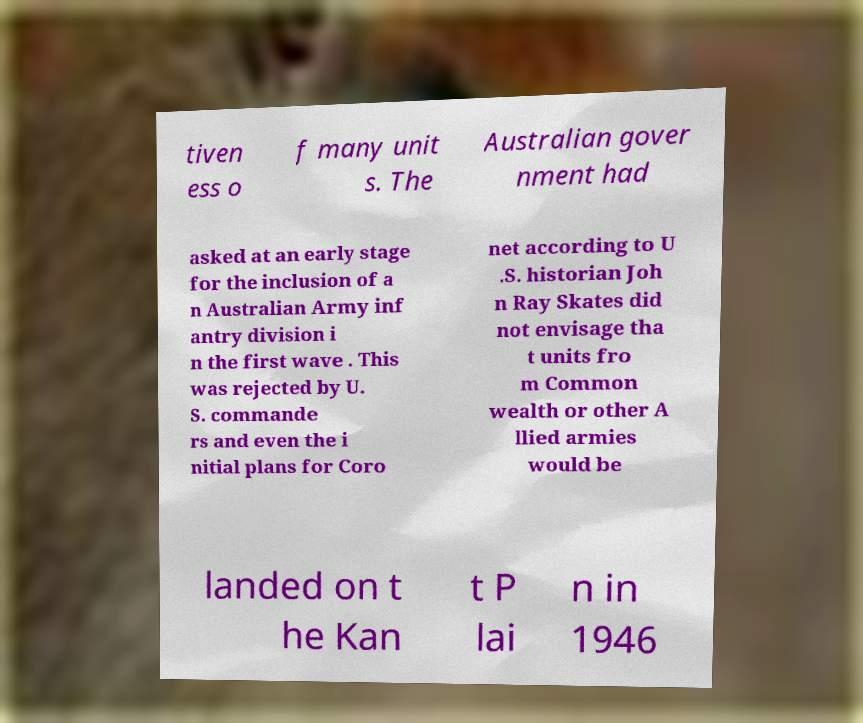There's text embedded in this image that I need extracted. Can you transcribe it verbatim? tiven ess o f many unit s. The Australian gover nment had asked at an early stage for the inclusion of a n Australian Army inf antry division i n the first wave . This was rejected by U. S. commande rs and even the i nitial plans for Coro net according to U .S. historian Joh n Ray Skates did not envisage tha t units fro m Common wealth or other A llied armies would be landed on t he Kan t P lai n in 1946 